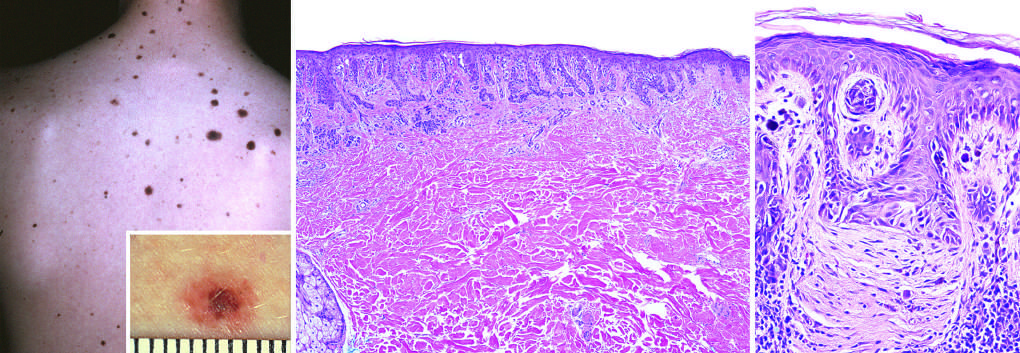what corresponds to the less pigmented flat peripheral rim?
Answer the question using a single word or phrase. An asymmetric shoulder of exclusively junctional melanocytes 